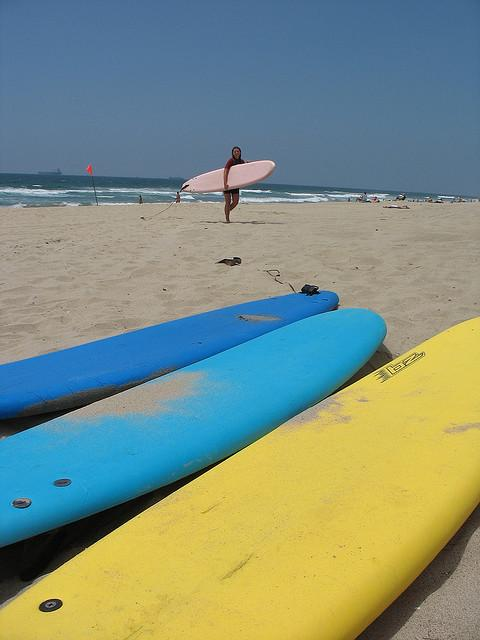Which music group would be able to use all of these boards without sharing? beach boys 